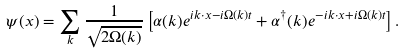<formula> <loc_0><loc_0><loc_500><loc_500>\psi ( x ) = \sum _ { k } \frac { 1 } { \sqrt { 2 \Omega ( k ) } } \left [ \alpha ( { k } ) e ^ { i { k } \cdot { x } - i \Omega ( k ) t } + \alpha ^ { \dagger } ( { k } ) e ^ { - i { k } \cdot { x } + i \Omega ( k ) t } \right ] .</formula> 